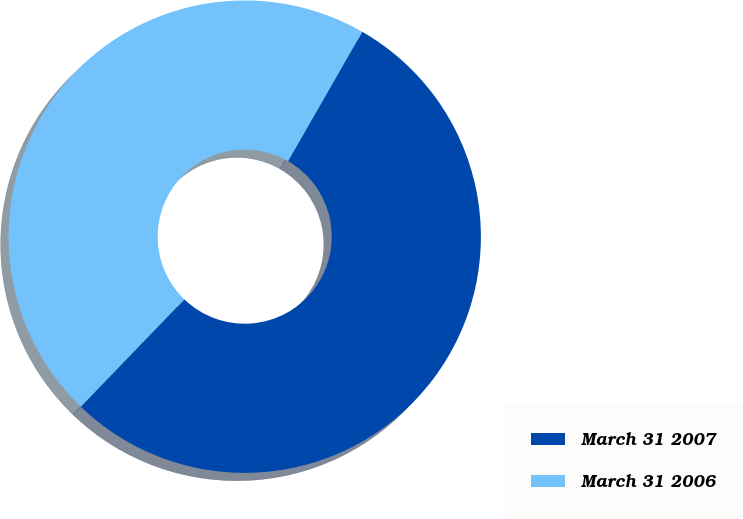Convert chart. <chart><loc_0><loc_0><loc_500><loc_500><pie_chart><fcel>March 31 2007<fcel>March 31 2006<nl><fcel>53.92%<fcel>46.08%<nl></chart> 